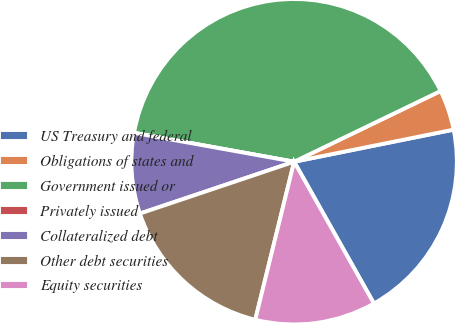Convert chart. <chart><loc_0><loc_0><loc_500><loc_500><pie_chart><fcel>US Treasury and federal<fcel>Obligations of states and<fcel>Government issued or<fcel>Privately issued<fcel>Collateralized debt<fcel>Other debt securities<fcel>Equity securities<nl><fcel>20.0%<fcel>4.0%<fcel>40.0%<fcel>0.0%<fcel>8.0%<fcel>16.0%<fcel>12.0%<nl></chart> 